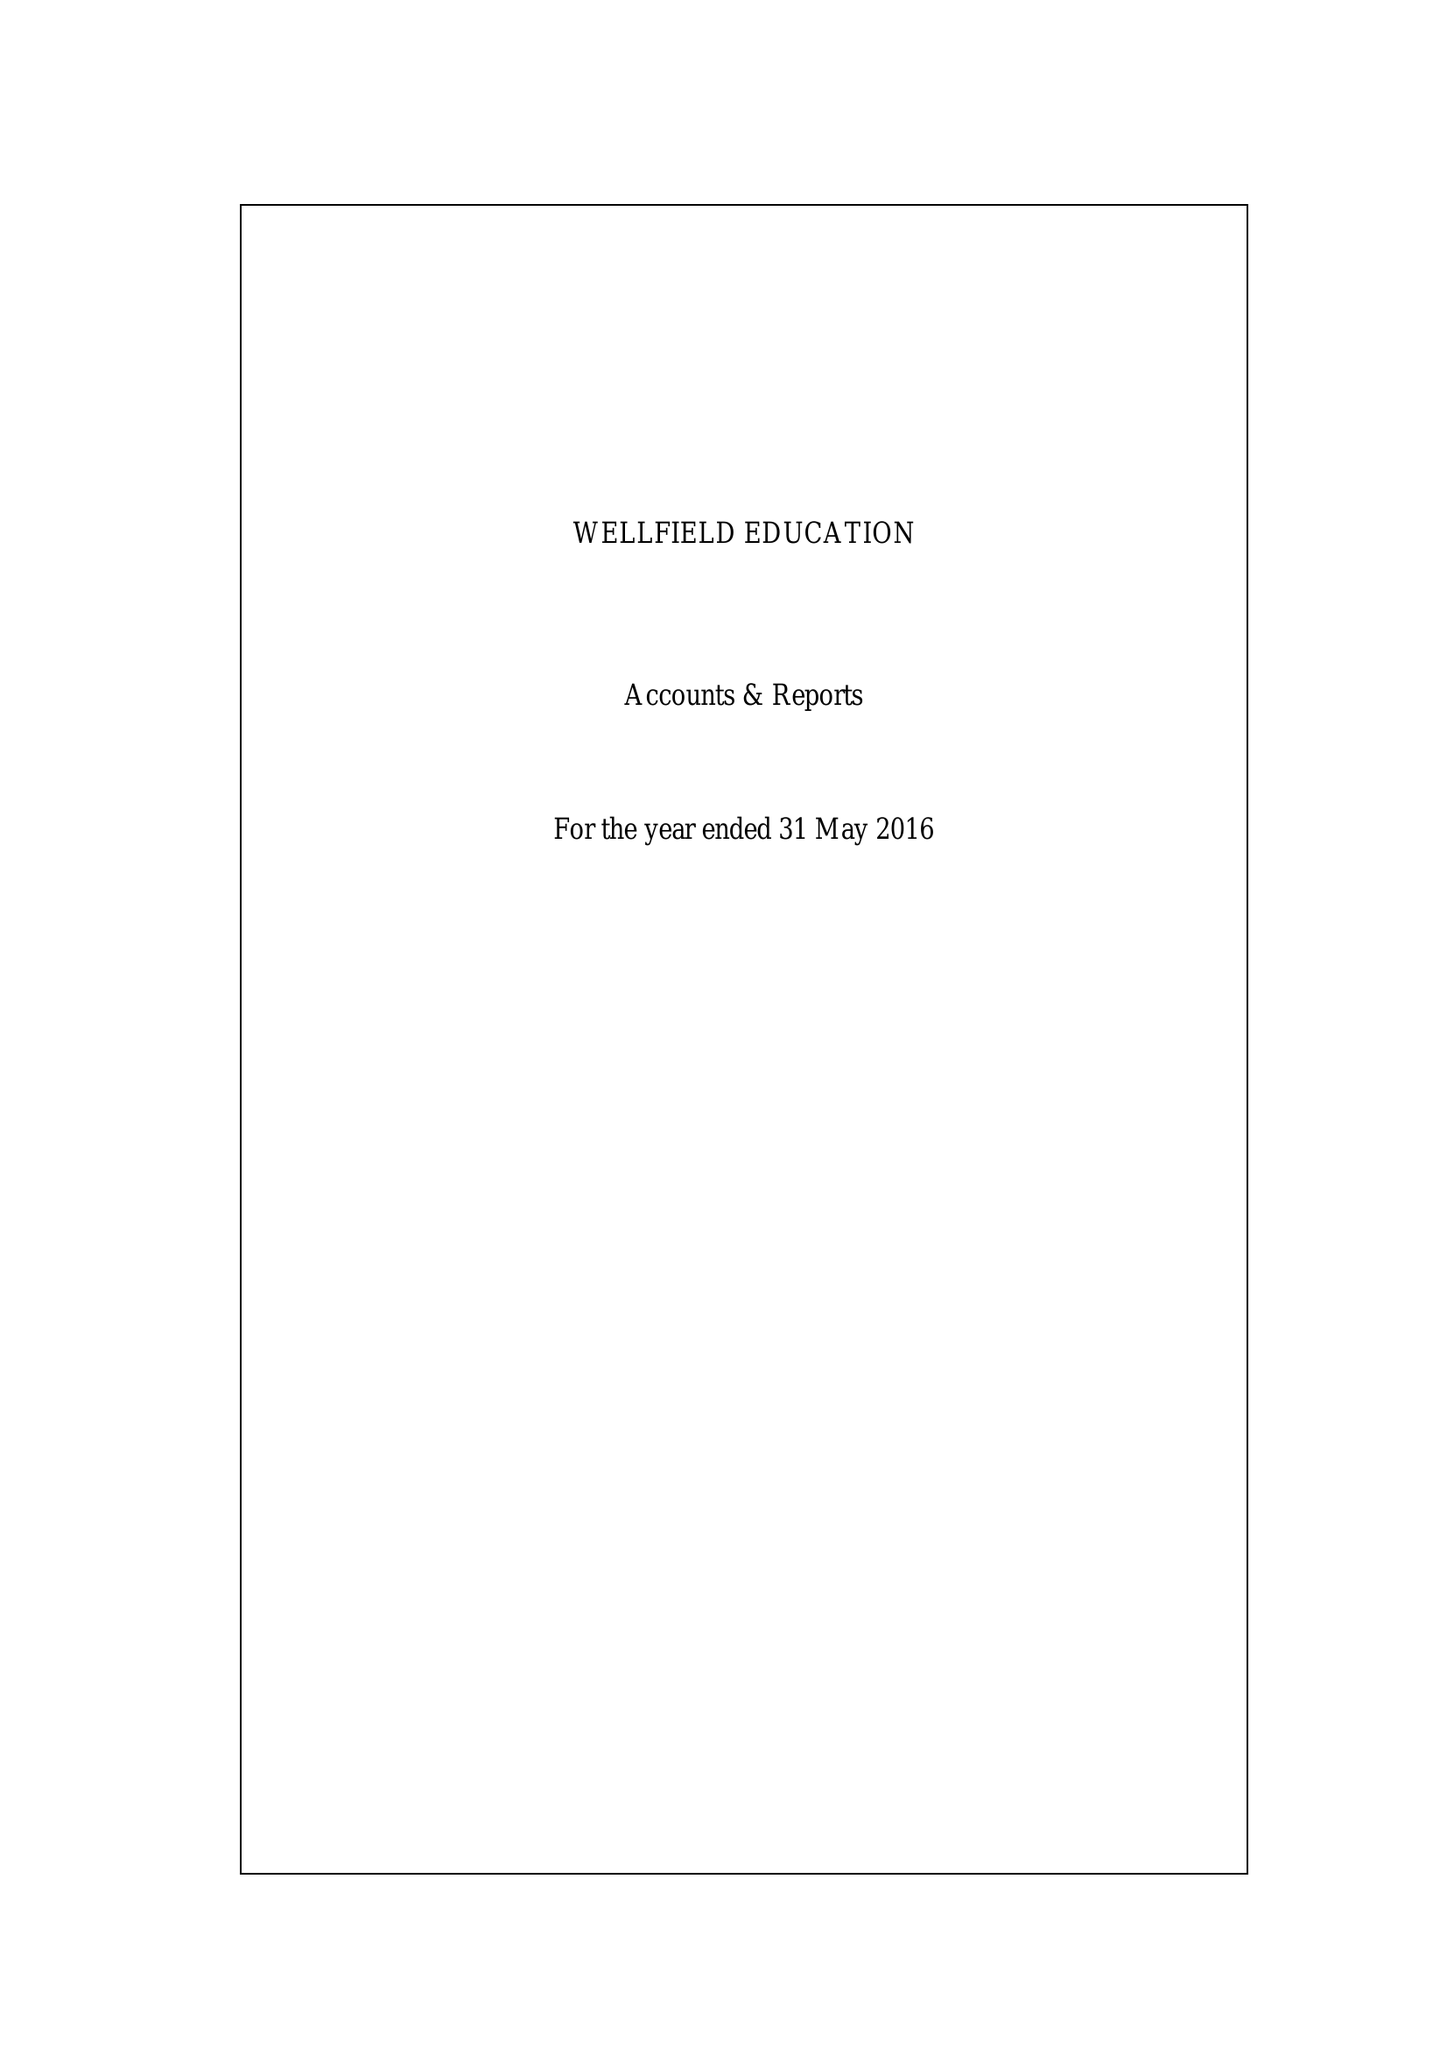What is the value for the address__postcode?
Answer the question using a single word or phrase. SW16 1HS 